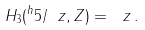Convert formula to latex. <formula><loc_0><loc_0><loc_500><loc_500>H _ { 3 } ( ^ { h } { 5 } / \ z , Z ) = \ z \, .</formula> 